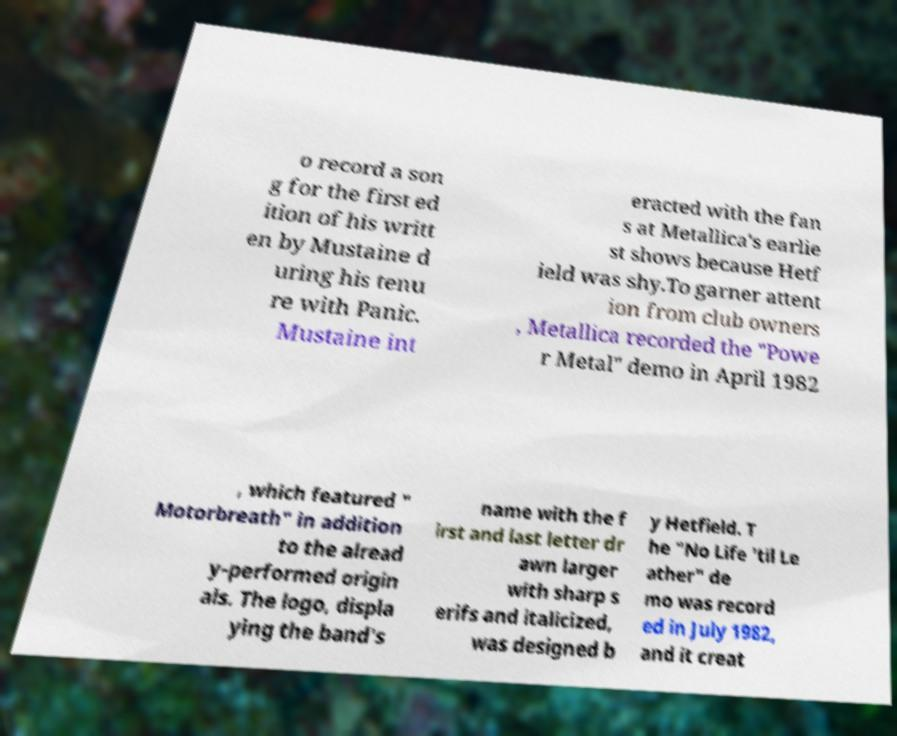What messages or text are displayed in this image? I need them in a readable, typed format. o record a son g for the first ed ition of his writt en by Mustaine d uring his tenu re with Panic. Mustaine int eracted with the fan s at Metallica's earlie st shows because Hetf ield was shy.To garner attent ion from club owners , Metallica recorded the "Powe r Metal" demo in April 1982 , which featured " Motorbreath" in addition to the alread y-performed origin als. The logo, displa ying the band's name with the f irst and last letter dr awn larger with sharp s erifs and italicized, was designed b y Hetfield. T he "No Life 'til Le ather" de mo was record ed in July 1982, and it creat 